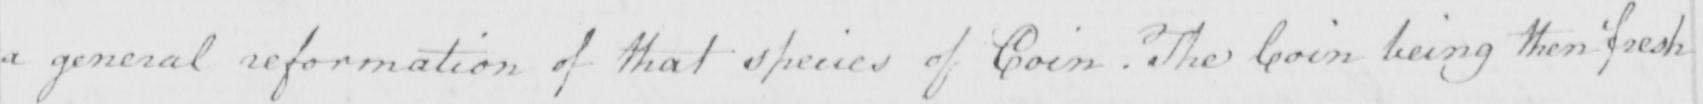Please transcribe the handwritten text in this image. a general reformation of that species of Coin  . The Coin being then fresh 